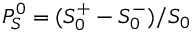Convert formula to latex. <formula><loc_0><loc_0><loc_500><loc_500>P _ { S } ^ { 0 } = ( S _ { 0 } ^ { + } - S _ { 0 } ^ { - } ) / S _ { 0 }</formula> 